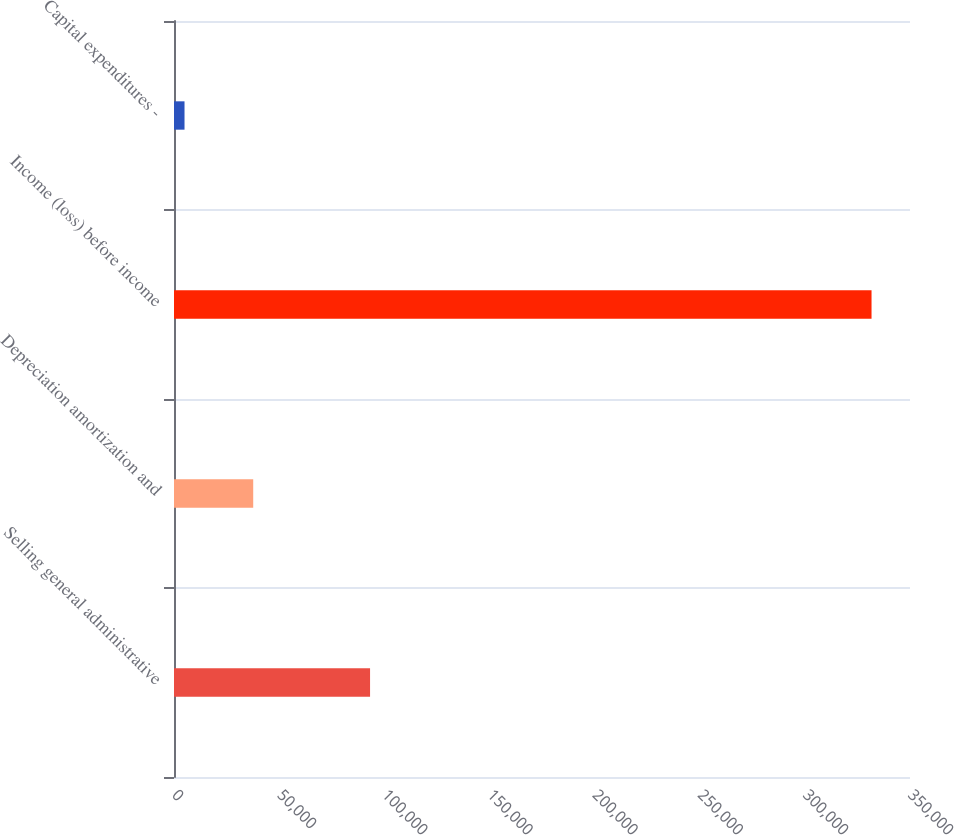Convert chart. <chart><loc_0><loc_0><loc_500><loc_500><bar_chart><fcel>Selling general administrative<fcel>Depreciation amortization and<fcel>Income (loss) before income<fcel>Capital expenditures -<nl><fcel>93236<fcel>37671<fcel>331710<fcel>5000<nl></chart> 